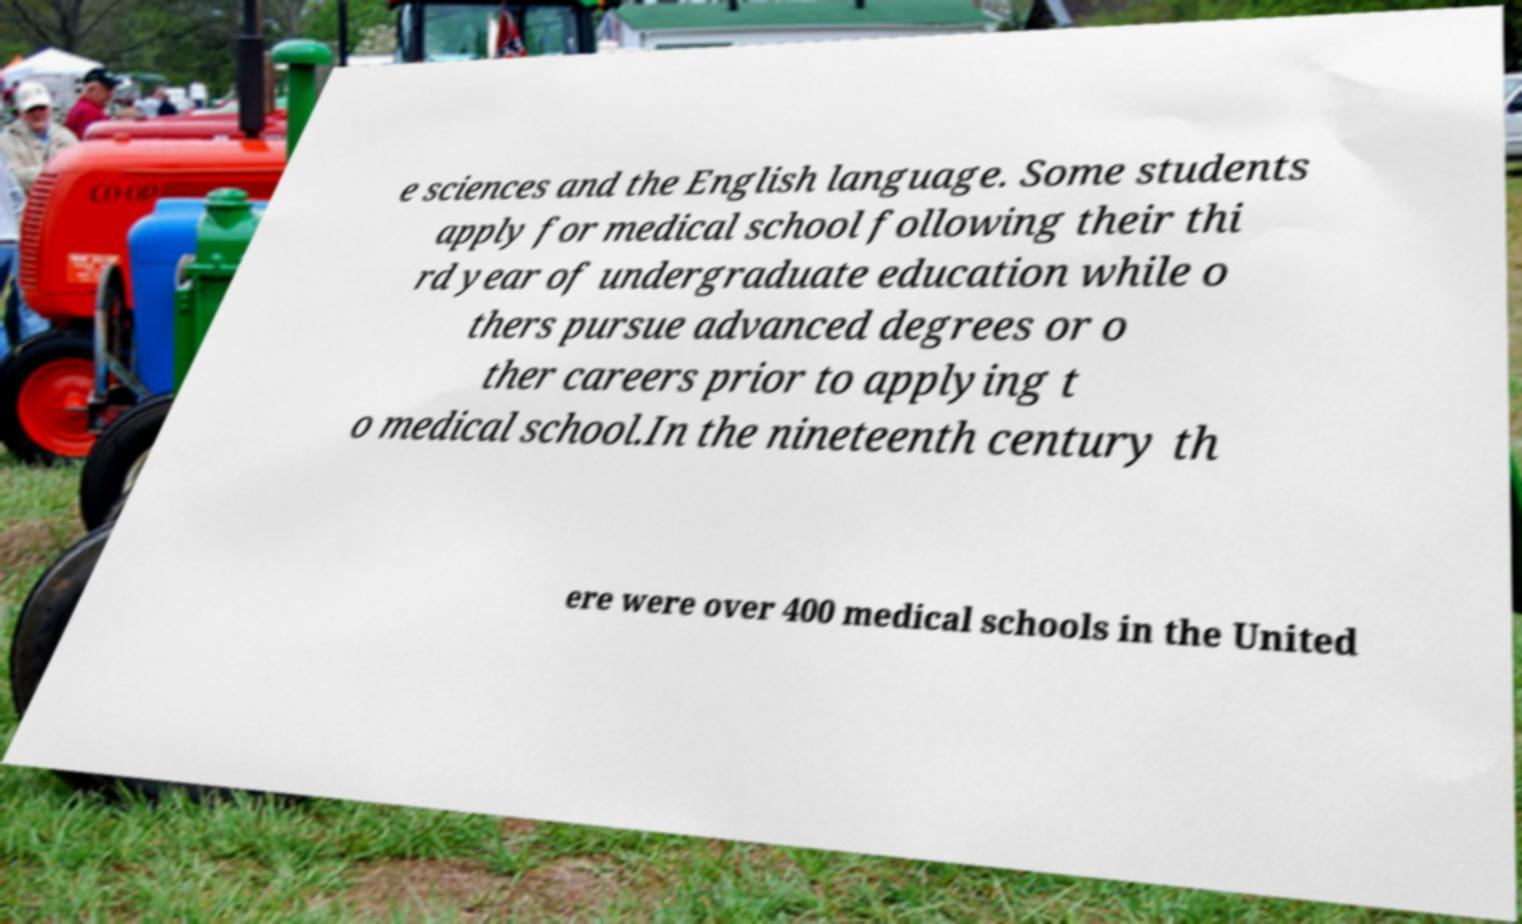What messages or text are displayed in this image? I need them in a readable, typed format. e sciences and the English language. Some students apply for medical school following their thi rd year of undergraduate education while o thers pursue advanced degrees or o ther careers prior to applying t o medical school.In the nineteenth century th ere were over 400 medical schools in the United 